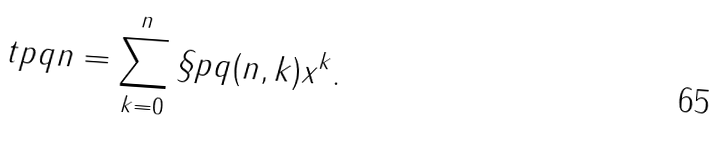<formula> <loc_0><loc_0><loc_500><loc_500>\ t p q { n } = \sum _ { k = 0 } ^ { n } \S p q ( n , k ) x ^ { k } .</formula> 